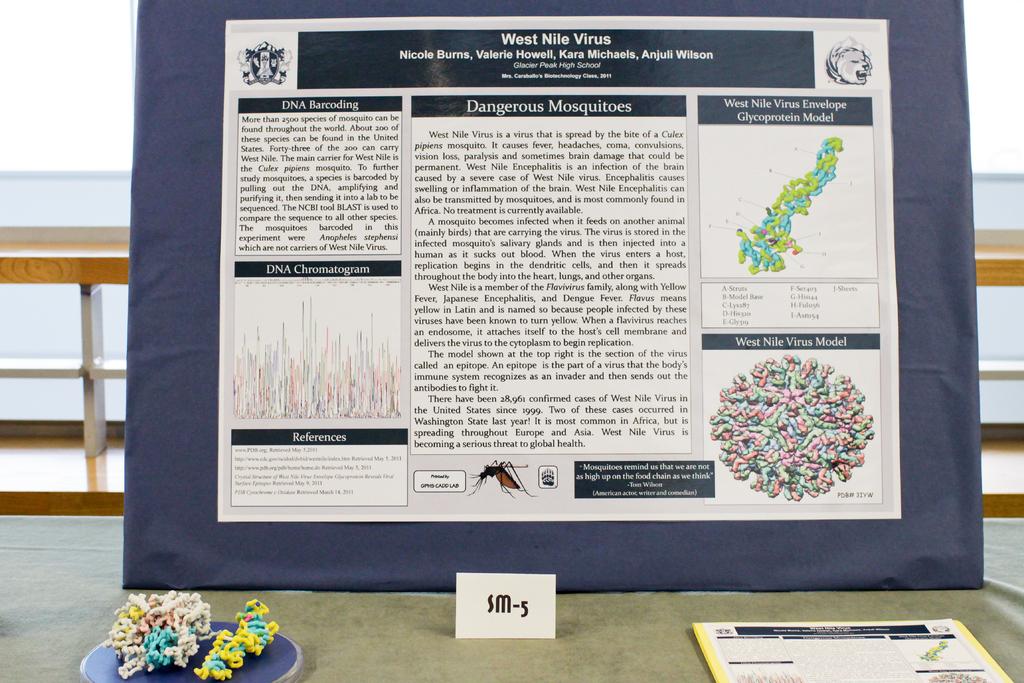What virus is this talking about?
Make the answer very short. West nile. 